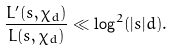<formula> <loc_0><loc_0><loc_500><loc_500>\frac { L ^ { \prime } ( s , \chi _ { d } ) } { L ( s , \chi _ { d } ) } \ll \log ^ { 2 } ( | s | d ) .</formula> 